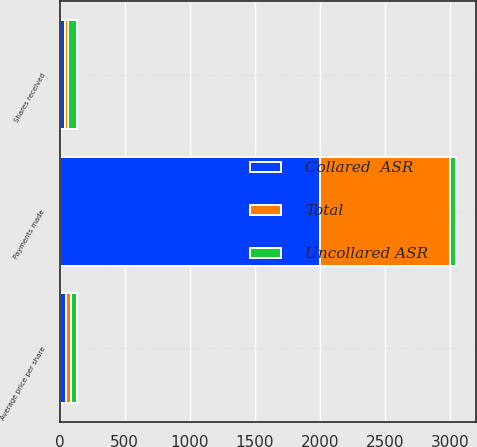Convert chart to OTSL. <chart><loc_0><loc_0><loc_500><loc_500><stacked_bar_chart><ecel><fcel>Shares received<fcel>Payments made<fcel>Average price per share<nl><fcel>Collared  ASR<fcel>43.9<fcel>2000<fcel>45.6<nl><fcel>Total<fcel>21.9<fcel>1000<fcel>45.57<nl><fcel>Uncollared ASR<fcel>65.8<fcel>45.595<fcel>45.59<nl></chart> 